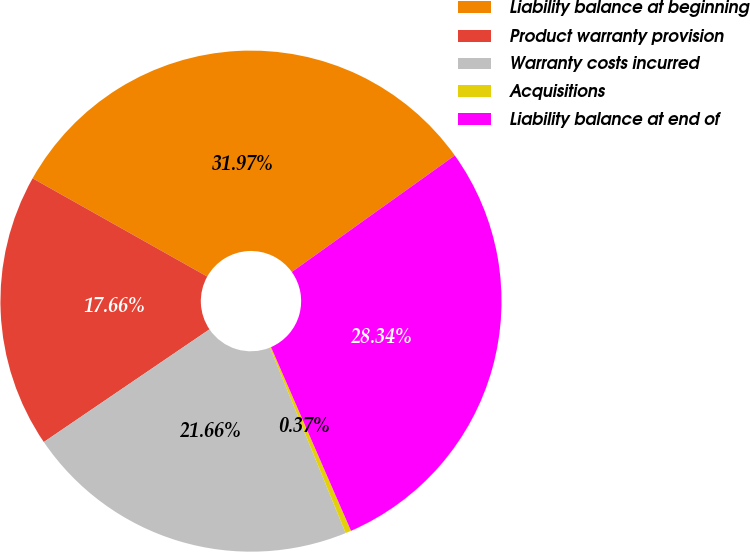Convert chart. <chart><loc_0><loc_0><loc_500><loc_500><pie_chart><fcel>Liability balance at beginning<fcel>Product warranty provision<fcel>Warranty costs incurred<fcel>Acquisitions<fcel>Liability balance at end of<nl><fcel>31.97%<fcel>17.66%<fcel>21.66%<fcel>0.37%<fcel>28.34%<nl></chart> 